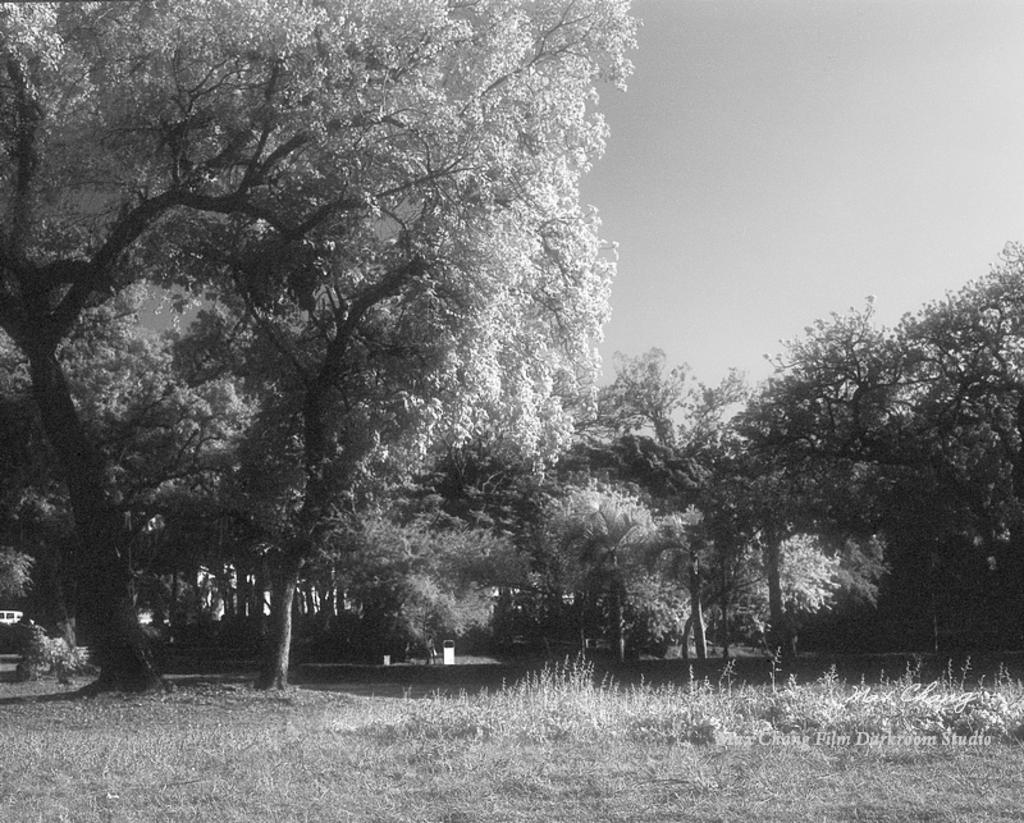What is the color scheme of the image? The image is in black and white. What can be seen in the center of the image? There are trees in the center of the image. What type of vegetation is at the bottom of the image? There is grass at the bottom of the image. What part of the sky is visible in the image? The sky is visible at the top right of the image. How many babies are comfortably sleeping on a spoon in the image? There are no babies or spoons present in the image. 